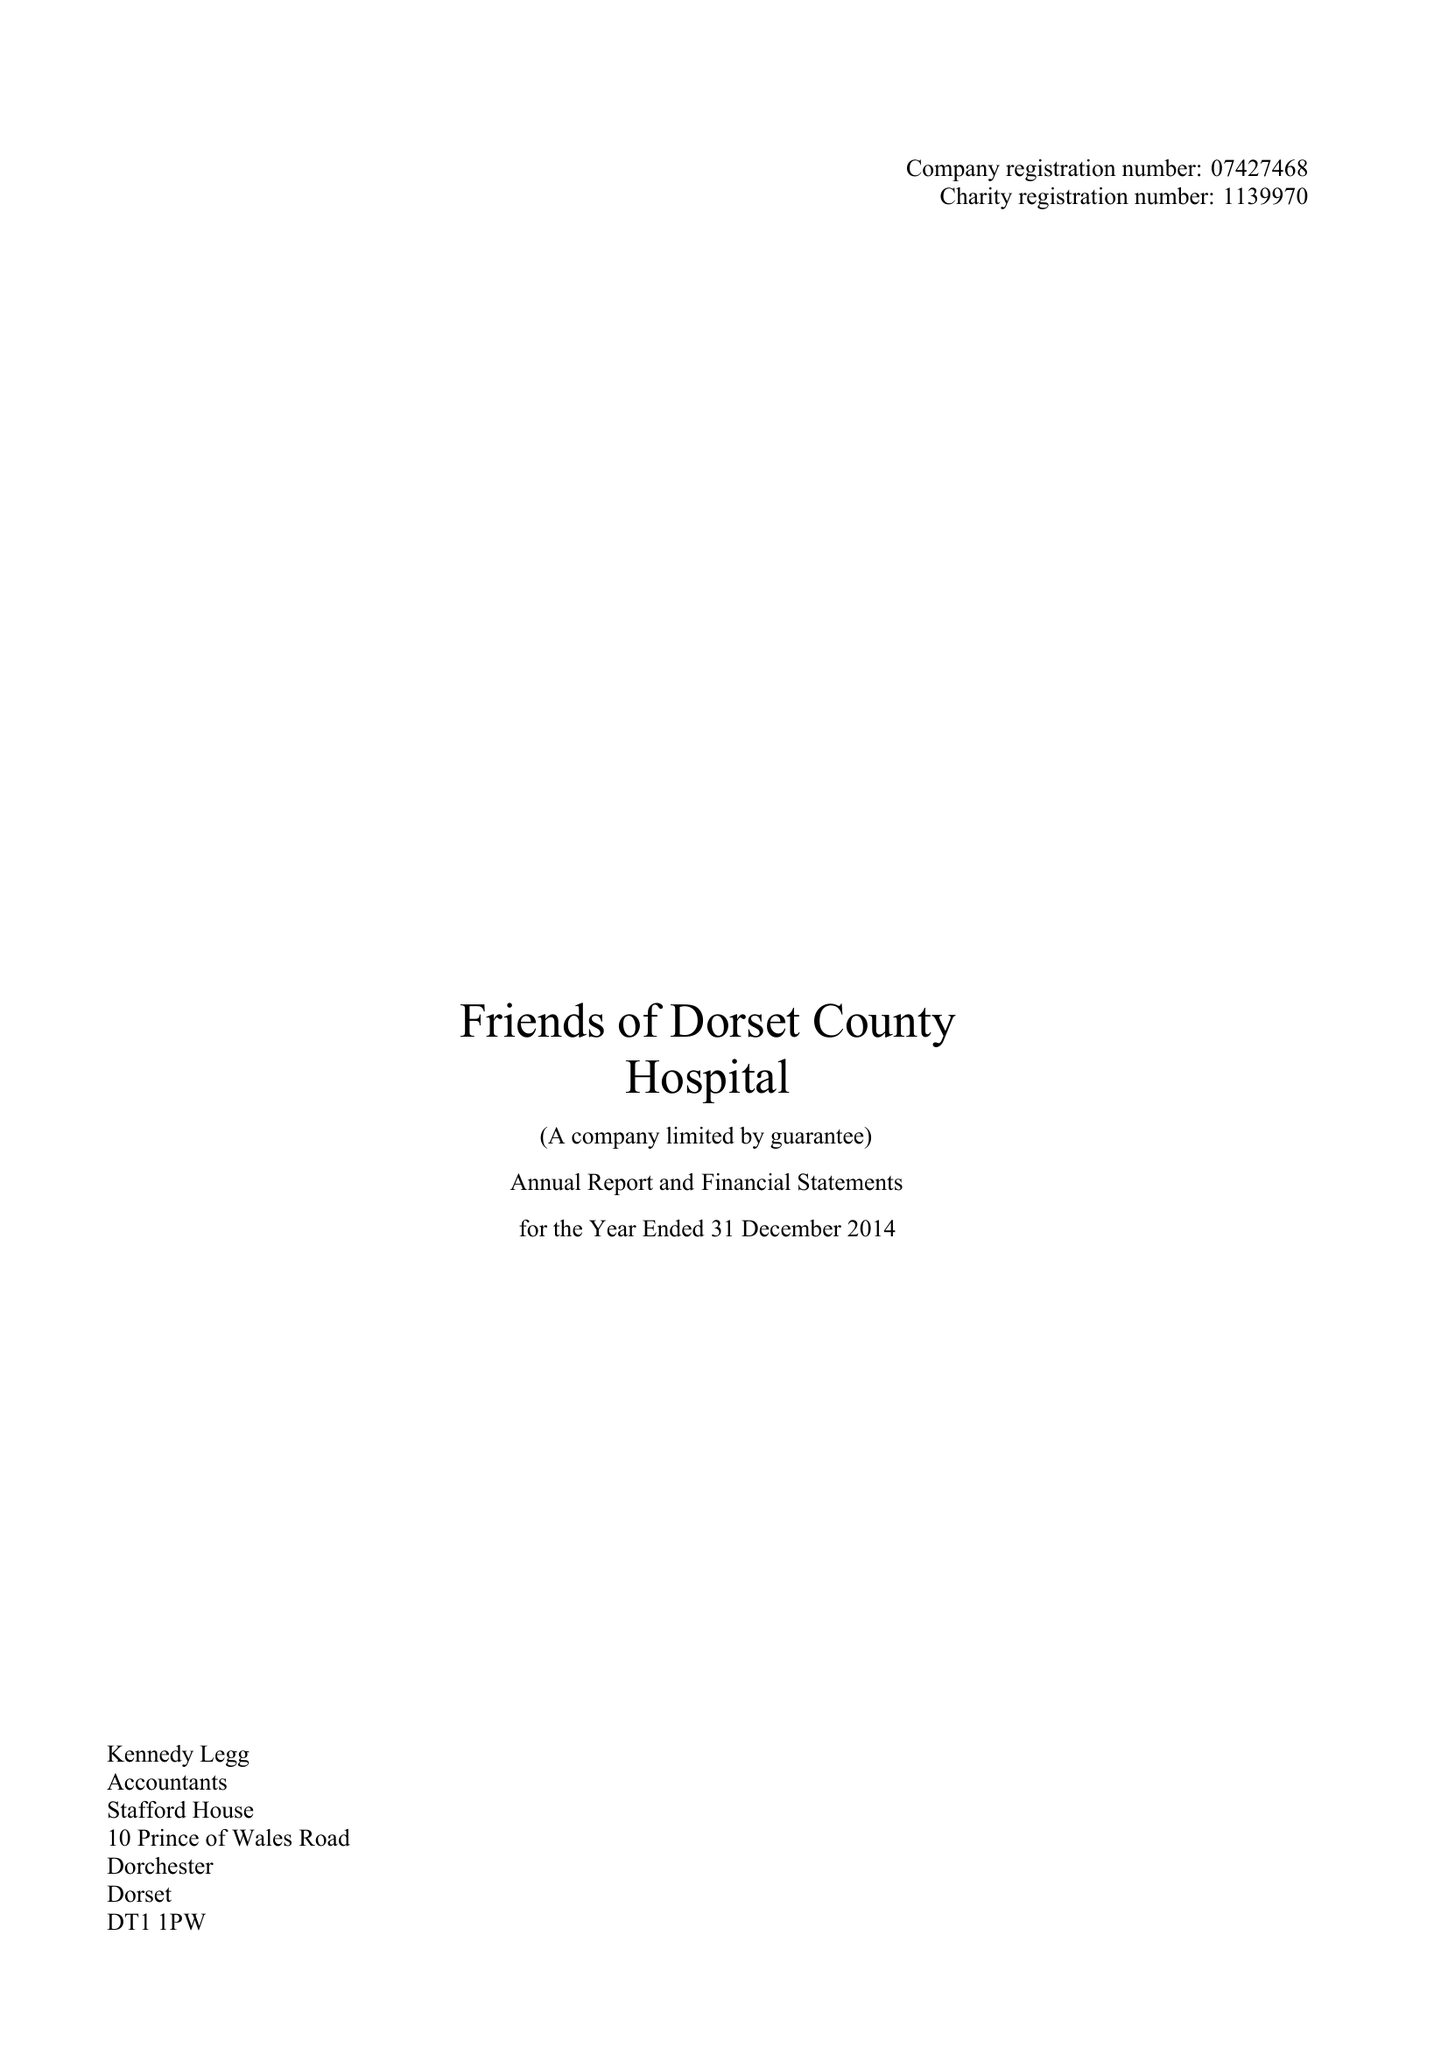What is the value for the charity_name?
Answer the question using a single word or phrase. Friends Of Dorset County Hospital 